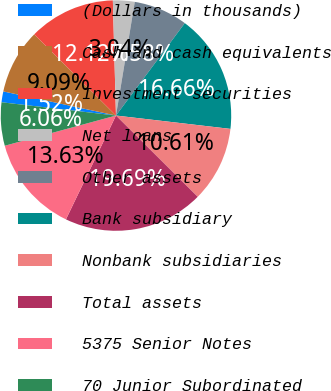<chart> <loc_0><loc_0><loc_500><loc_500><pie_chart><fcel>(Dollars in thousands)<fcel>Cash and cash equivalents<fcel>Investment securities<fcel>Net loans<fcel>Other assets<fcel>Bank subsidiary<fcel>Nonbank subsidiaries<fcel>Total assets<fcel>5375 Senior Notes<fcel>70 Junior Subordinated<nl><fcel>1.52%<fcel>9.09%<fcel>12.12%<fcel>3.04%<fcel>7.58%<fcel>16.66%<fcel>10.61%<fcel>19.69%<fcel>13.63%<fcel>6.06%<nl></chart> 